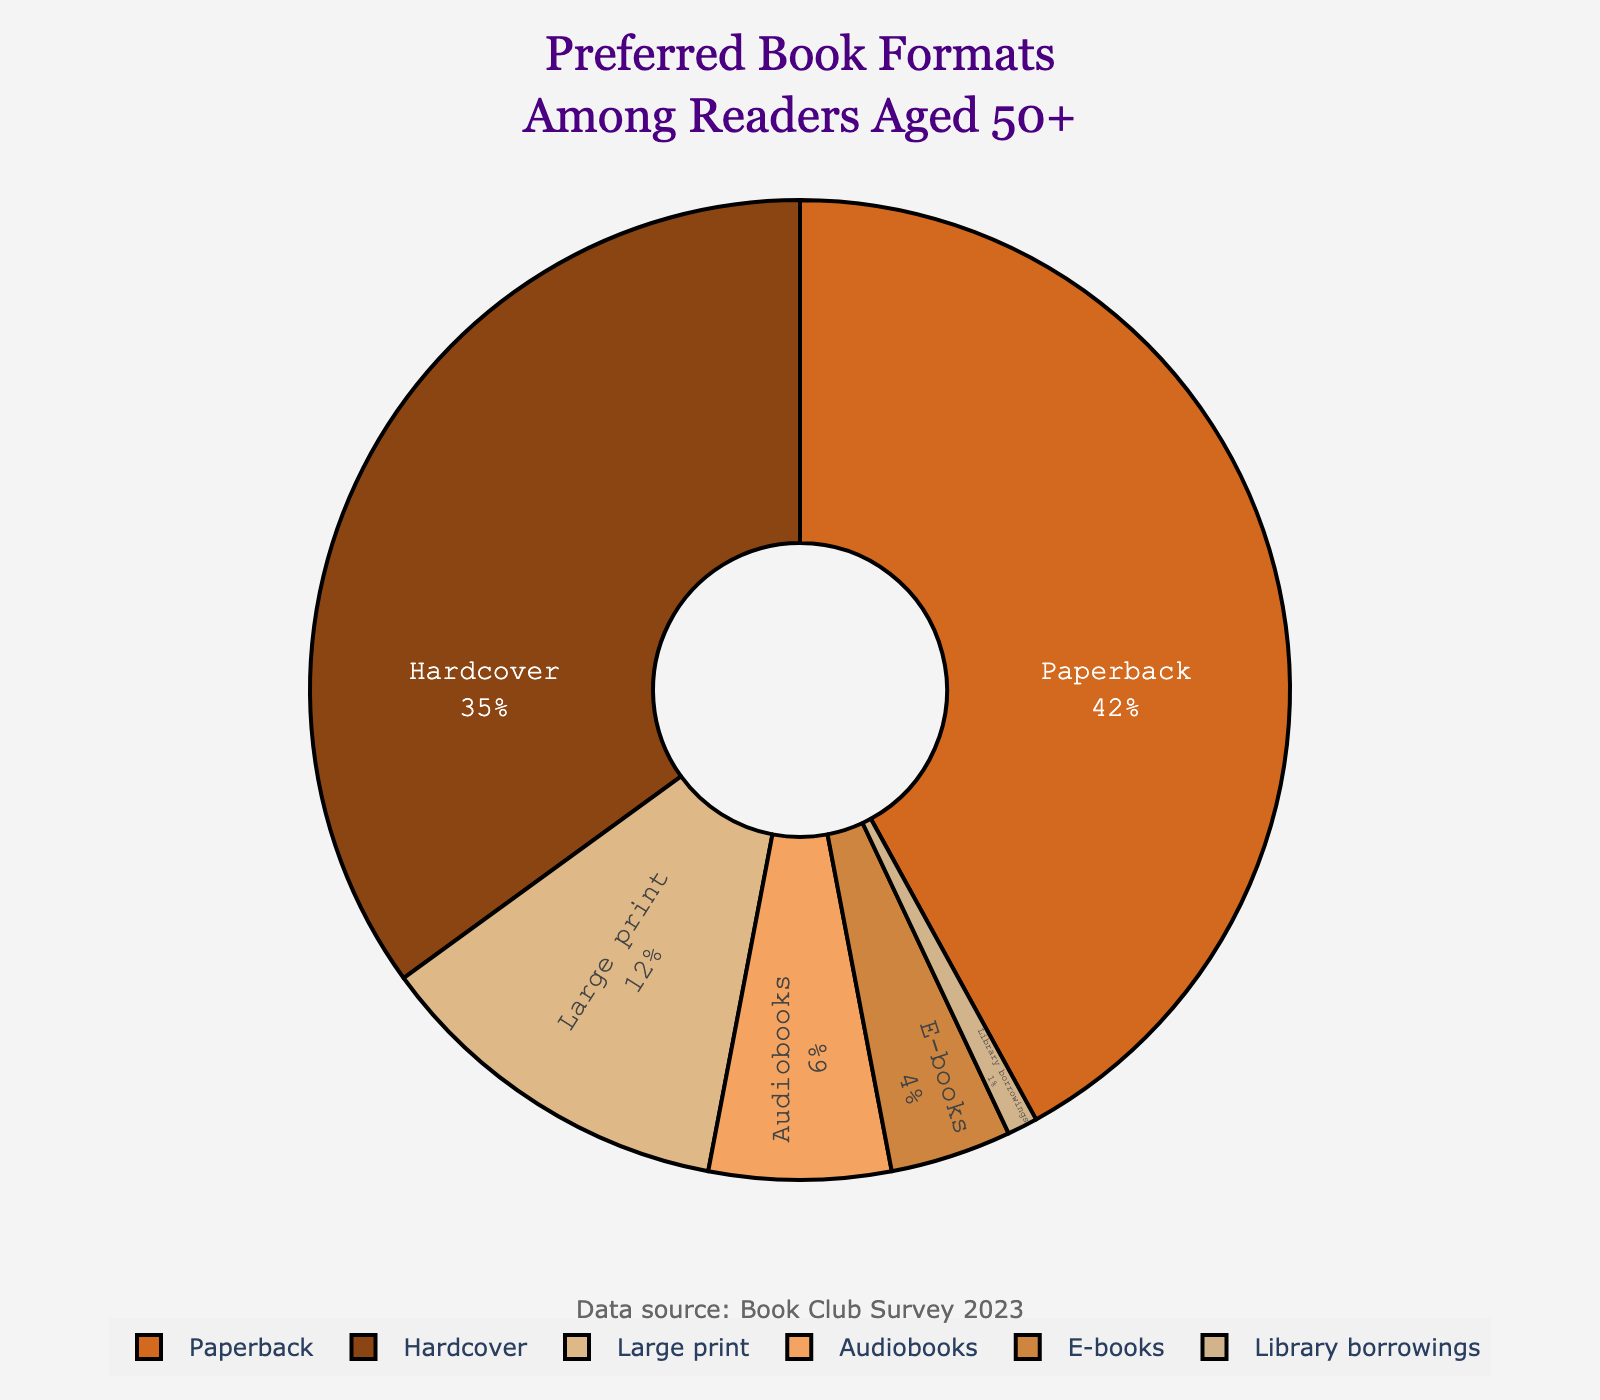Which format is preferred by the highest percentage of readers? To find the preferred book format with the highest percentage, look for the segment with the largest proportion in the pie chart. The largest segment is labeled "Paperback," which has a percentage of 42%.
Answer: Paperback What is the combined percentage of readers who prefer hardcover and large print formats? To find the combined percentage, sum the individual percentages of readers who prefer hardcover (35%) and large print (12%). Thus, 35 + 12 = 47%.
Answer: 47% Which format is preferred by a smaller percentage of readers, audiobooks or e-books? Compare the segments labeled "Audiobooks" and "E-books" to find the smaller percentage. Audiobooks have 6%, while E-books have 4%. Therefore, E-books are preferred by a smaller percentage.
Answer: E-books How much greater is the percentage of readers preferring paperbacks compared to those preferring audiobooks? Subtract the percentage of readers preferring audiobooks (6%) from those preferring paperbacks (42%). The difference is 42 - 6 = 36%.
Answer: 36% What is the total percentage of readers preferring either audiobooks or e-books? To find the total percentage, sum the individual percentages of readers preferring audiobooks (6%) and e-books (4%). Thus, 6 + 4 = 10%.
Answer: 10% Which book format has the smallest representation among readers aged 50 and above? Look for the smallest segment in the pie chart. The smallest segment is labeled "Library borrowings," which has a percentage of 1%.
Answer: Library borrowings By how many percentage points does paperback preference exceed hardcover preference? Subtract the percentage of readers preferring hardcover (35%) from those preferring paperbacks (42%). The difference is 42 - 35 = 7 percentage points.
Answer: 7 percentage points What percentage of readers prefer formats other than hardcover and paperback? To find this, sum the percentages of all formats other than hardcover (35%) and paperback (42%): Large print (12%), Audiobooks (6%), E-books (4%), and Library borrowings (1%). Adding these gives 12 + 6 + 4 + 1 = 23%.
Answer: 23% Which format has a preference percentage that is exactly one-third of the preference for hardcovers? To find one-third of the hardcover preference (35%), divide it by 3, resulting in approximately 11.67%. The closest percentage in the chart to this value is large print at 12%.
Answer: Large print How does the combined preference for audiobooks and e-books compare to the preference for large print? First, sum the percentages for audiobooks (6%) and e-books (4%), which gives 6 + 4 = 10%. The preference for large print alone is 12%, which is higher than the combined preference of audiobooks and e-books.
Answer: Large print is higher 